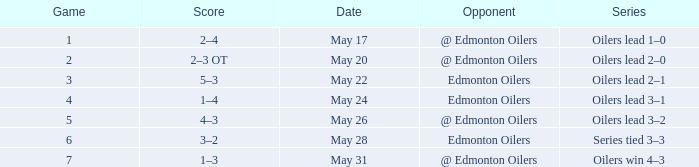Opponent of edmonton oilers, and a Game of 3 is what series? Oilers lead 2–1. 